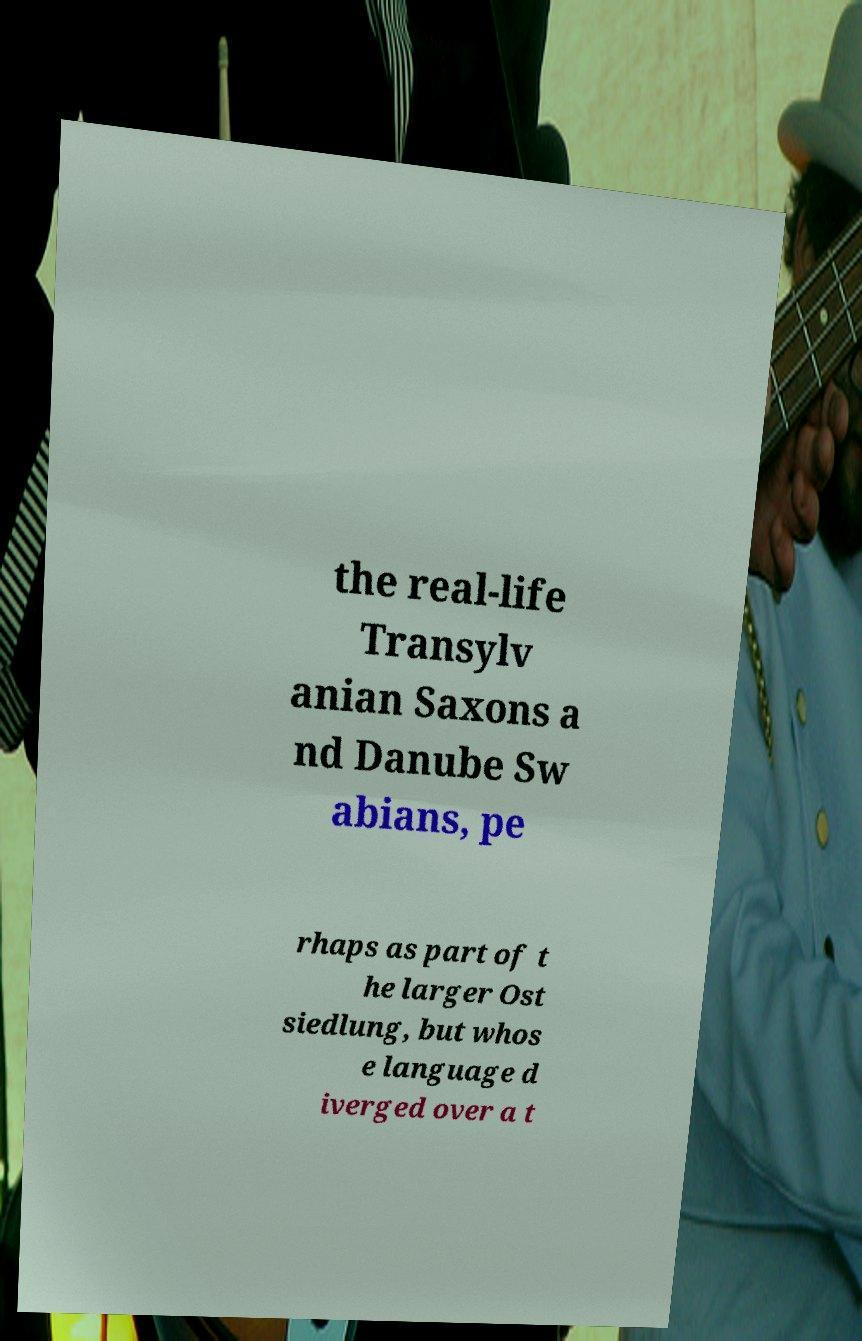Could you assist in decoding the text presented in this image and type it out clearly? the real-life Transylv anian Saxons a nd Danube Sw abians, pe rhaps as part of t he larger Ost siedlung, but whos e language d iverged over a t 